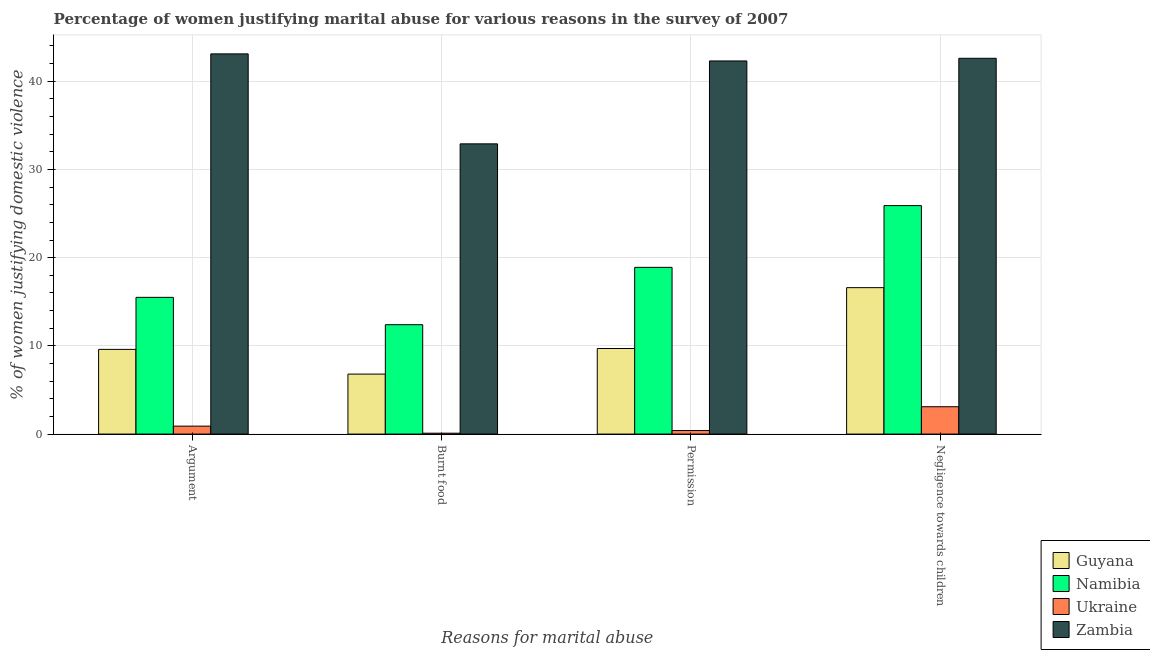How many different coloured bars are there?
Give a very brief answer. 4. What is the label of the 1st group of bars from the left?
Provide a succinct answer. Argument. What is the percentage of women justifying abuse for going without permission in Namibia?
Offer a terse response. 18.9. Across all countries, what is the maximum percentage of women justifying abuse for burning food?
Give a very brief answer. 32.9. In which country was the percentage of women justifying abuse in the case of an argument maximum?
Make the answer very short. Zambia. In which country was the percentage of women justifying abuse in the case of an argument minimum?
Keep it short and to the point. Ukraine. What is the total percentage of women justifying abuse for burning food in the graph?
Your answer should be compact. 52.2. What is the difference between the percentage of women justifying abuse for going without permission in Namibia and that in Zambia?
Give a very brief answer. -23.4. What is the difference between the percentage of women justifying abuse for showing negligence towards children in Guyana and the percentage of women justifying abuse in the case of an argument in Namibia?
Offer a terse response. 1.1. What is the average percentage of women justifying abuse in the case of an argument per country?
Provide a succinct answer. 17.27. What is the ratio of the percentage of women justifying abuse in the case of an argument in Ukraine to that in Namibia?
Your answer should be very brief. 0.06. What is the difference between the highest and the second highest percentage of women justifying abuse for going without permission?
Provide a short and direct response. 23.4. What is the difference between the highest and the lowest percentage of women justifying abuse for showing negligence towards children?
Give a very brief answer. 39.5. Is it the case that in every country, the sum of the percentage of women justifying abuse for burning food and percentage of women justifying abuse for going without permission is greater than the sum of percentage of women justifying abuse for showing negligence towards children and percentage of women justifying abuse in the case of an argument?
Provide a short and direct response. No. What does the 1st bar from the left in Argument represents?
Provide a short and direct response. Guyana. What does the 1st bar from the right in Negligence towards children represents?
Ensure brevity in your answer.  Zambia. How many bars are there?
Your response must be concise. 16. What is the difference between two consecutive major ticks on the Y-axis?
Your response must be concise. 10. Does the graph contain any zero values?
Give a very brief answer. No. Where does the legend appear in the graph?
Ensure brevity in your answer.  Bottom right. How many legend labels are there?
Your response must be concise. 4. What is the title of the graph?
Your response must be concise. Percentage of women justifying marital abuse for various reasons in the survey of 2007. Does "Guyana" appear as one of the legend labels in the graph?
Your response must be concise. Yes. What is the label or title of the X-axis?
Your answer should be compact. Reasons for marital abuse. What is the label or title of the Y-axis?
Provide a succinct answer. % of women justifying domestic violence. What is the % of women justifying domestic violence in Ukraine in Argument?
Your answer should be very brief. 0.9. What is the % of women justifying domestic violence in Zambia in Argument?
Your answer should be very brief. 43.1. What is the % of women justifying domestic violence of Zambia in Burnt food?
Offer a very short reply. 32.9. What is the % of women justifying domestic violence of Zambia in Permission?
Offer a very short reply. 42.3. What is the % of women justifying domestic violence of Namibia in Negligence towards children?
Make the answer very short. 25.9. What is the % of women justifying domestic violence in Ukraine in Negligence towards children?
Keep it short and to the point. 3.1. What is the % of women justifying domestic violence in Zambia in Negligence towards children?
Provide a short and direct response. 42.6. Across all Reasons for marital abuse, what is the maximum % of women justifying domestic violence of Guyana?
Your answer should be very brief. 16.6. Across all Reasons for marital abuse, what is the maximum % of women justifying domestic violence of Namibia?
Your response must be concise. 25.9. Across all Reasons for marital abuse, what is the maximum % of women justifying domestic violence in Zambia?
Your response must be concise. 43.1. Across all Reasons for marital abuse, what is the minimum % of women justifying domestic violence in Guyana?
Offer a terse response. 6.8. Across all Reasons for marital abuse, what is the minimum % of women justifying domestic violence in Namibia?
Offer a terse response. 12.4. Across all Reasons for marital abuse, what is the minimum % of women justifying domestic violence in Ukraine?
Make the answer very short. 0.1. Across all Reasons for marital abuse, what is the minimum % of women justifying domestic violence of Zambia?
Offer a very short reply. 32.9. What is the total % of women justifying domestic violence in Guyana in the graph?
Offer a terse response. 42.7. What is the total % of women justifying domestic violence in Namibia in the graph?
Give a very brief answer. 72.7. What is the total % of women justifying domestic violence of Ukraine in the graph?
Ensure brevity in your answer.  4.5. What is the total % of women justifying domestic violence of Zambia in the graph?
Your response must be concise. 160.9. What is the difference between the % of women justifying domestic violence of Guyana in Argument and that in Burnt food?
Your response must be concise. 2.8. What is the difference between the % of women justifying domestic violence in Namibia in Argument and that in Permission?
Make the answer very short. -3.4. What is the difference between the % of women justifying domestic violence of Guyana in Argument and that in Negligence towards children?
Offer a very short reply. -7. What is the difference between the % of women justifying domestic violence of Ukraine in Argument and that in Negligence towards children?
Your answer should be very brief. -2.2. What is the difference between the % of women justifying domestic violence in Zambia in Argument and that in Negligence towards children?
Offer a very short reply. 0.5. What is the difference between the % of women justifying domestic violence of Guyana in Burnt food and that in Permission?
Offer a very short reply. -2.9. What is the difference between the % of women justifying domestic violence in Namibia in Burnt food and that in Permission?
Your answer should be very brief. -6.5. What is the difference between the % of women justifying domestic violence of Ukraine in Burnt food and that in Permission?
Keep it short and to the point. -0.3. What is the difference between the % of women justifying domestic violence of Ukraine in Burnt food and that in Negligence towards children?
Your answer should be compact. -3. What is the difference between the % of women justifying domestic violence in Namibia in Permission and that in Negligence towards children?
Provide a succinct answer. -7. What is the difference between the % of women justifying domestic violence in Guyana in Argument and the % of women justifying domestic violence in Zambia in Burnt food?
Make the answer very short. -23.3. What is the difference between the % of women justifying domestic violence in Namibia in Argument and the % of women justifying domestic violence in Zambia in Burnt food?
Keep it short and to the point. -17.4. What is the difference between the % of women justifying domestic violence of Ukraine in Argument and the % of women justifying domestic violence of Zambia in Burnt food?
Offer a terse response. -32. What is the difference between the % of women justifying domestic violence of Guyana in Argument and the % of women justifying domestic violence of Ukraine in Permission?
Provide a succinct answer. 9.2. What is the difference between the % of women justifying domestic violence in Guyana in Argument and the % of women justifying domestic violence in Zambia in Permission?
Your response must be concise. -32.7. What is the difference between the % of women justifying domestic violence of Namibia in Argument and the % of women justifying domestic violence of Zambia in Permission?
Offer a terse response. -26.8. What is the difference between the % of women justifying domestic violence in Ukraine in Argument and the % of women justifying domestic violence in Zambia in Permission?
Your answer should be very brief. -41.4. What is the difference between the % of women justifying domestic violence of Guyana in Argument and the % of women justifying domestic violence of Namibia in Negligence towards children?
Your response must be concise. -16.3. What is the difference between the % of women justifying domestic violence in Guyana in Argument and the % of women justifying domestic violence in Ukraine in Negligence towards children?
Provide a short and direct response. 6.5. What is the difference between the % of women justifying domestic violence in Guyana in Argument and the % of women justifying domestic violence in Zambia in Negligence towards children?
Your response must be concise. -33. What is the difference between the % of women justifying domestic violence of Namibia in Argument and the % of women justifying domestic violence of Ukraine in Negligence towards children?
Offer a terse response. 12.4. What is the difference between the % of women justifying domestic violence in Namibia in Argument and the % of women justifying domestic violence in Zambia in Negligence towards children?
Your answer should be very brief. -27.1. What is the difference between the % of women justifying domestic violence of Ukraine in Argument and the % of women justifying domestic violence of Zambia in Negligence towards children?
Offer a terse response. -41.7. What is the difference between the % of women justifying domestic violence in Guyana in Burnt food and the % of women justifying domestic violence in Namibia in Permission?
Provide a short and direct response. -12.1. What is the difference between the % of women justifying domestic violence in Guyana in Burnt food and the % of women justifying domestic violence in Ukraine in Permission?
Your answer should be compact. 6.4. What is the difference between the % of women justifying domestic violence in Guyana in Burnt food and the % of women justifying domestic violence in Zambia in Permission?
Keep it short and to the point. -35.5. What is the difference between the % of women justifying domestic violence in Namibia in Burnt food and the % of women justifying domestic violence in Ukraine in Permission?
Provide a short and direct response. 12. What is the difference between the % of women justifying domestic violence in Namibia in Burnt food and the % of women justifying domestic violence in Zambia in Permission?
Offer a very short reply. -29.9. What is the difference between the % of women justifying domestic violence of Ukraine in Burnt food and the % of women justifying domestic violence of Zambia in Permission?
Keep it short and to the point. -42.2. What is the difference between the % of women justifying domestic violence in Guyana in Burnt food and the % of women justifying domestic violence in Namibia in Negligence towards children?
Give a very brief answer. -19.1. What is the difference between the % of women justifying domestic violence in Guyana in Burnt food and the % of women justifying domestic violence in Zambia in Negligence towards children?
Your answer should be compact. -35.8. What is the difference between the % of women justifying domestic violence of Namibia in Burnt food and the % of women justifying domestic violence of Zambia in Negligence towards children?
Your answer should be very brief. -30.2. What is the difference between the % of women justifying domestic violence of Ukraine in Burnt food and the % of women justifying domestic violence of Zambia in Negligence towards children?
Give a very brief answer. -42.5. What is the difference between the % of women justifying domestic violence of Guyana in Permission and the % of women justifying domestic violence of Namibia in Negligence towards children?
Provide a succinct answer. -16.2. What is the difference between the % of women justifying domestic violence in Guyana in Permission and the % of women justifying domestic violence in Ukraine in Negligence towards children?
Your response must be concise. 6.6. What is the difference between the % of women justifying domestic violence in Guyana in Permission and the % of women justifying domestic violence in Zambia in Negligence towards children?
Your response must be concise. -32.9. What is the difference between the % of women justifying domestic violence of Namibia in Permission and the % of women justifying domestic violence of Zambia in Negligence towards children?
Provide a short and direct response. -23.7. What is the difference between the % of women justifying domestic violence in Ukraine in Permission and the % of women justifying domestic violence in Zambia in Negligence towards children?
Offer a very short reply. -42.2. What is the average % of women justifying domestic violence in Guyana per Reasons for marital abuse?
Ensure brevity in your answer.  10.68. What is the average % of women justifying domestic violence of Namibia per Reasons for marital abuse?
Your answer should be very brief. 18.18. What is the average % of women justifying domestic violence of Ukraine per Reasons for marital abuse?
Provide a succinct answer. 1.12. What is the average % of women justifying domestic violence of Zambia per Reasons for marital abuse?
Your response must be concise. 40.23. What is the difference between the % of women justifying domestic violence of Guyana and % of women justifying domestic violence of Ukraine in Argument?
Offer a terse response. 8.7. What is the difference between the % of women justifying domestic violence of Guyana and % of women justifying domestic violence of Zambia in Argument?
Make the answer very short. -33.5. What is the difference between the % of women justifying domestic violence of Namibia and % of women justifying domestic violence of Ukraine in Argument?
Keep it short and to the point. 14.6. What is the difference between the % of women justifying domestic violence of Namibia and % of women justifying domestic violence of Zambia in Argument?
Your response must be concise. -27.6. What is the difference between the % of women justifying domestic violence of Ukraine and % of women justifying domestic violence of Zambia in Argument?
Make the answer very short. -42.2. What is the difference between the % of women justifying domestic violence of Guyana and % of women justifying domestic violence of Ukraine in Burnt food?
Offer a terse response. 6.7. What is the difference between the % of women justifying domestic violence of Guyana and % of women justifying domestic violence of Zambia in Burnt food?
Ensure brevity in your answer.  -26.1. What is the difference between the % of women justifying domestic violence of Namibia and % of women justifying domestic violence of Ukraine in Burnt food?
Keep it short and to the point. 12.3. What is the difference between the % of women justifying domestic violence of Namibia and % of women justifying domestic violence of Zambia in Burnt food?
Keep it short and to the point. -20.5. What is the difference between the % of women justifying domestic violence in Ukraine and % of women justifying domestic violence in Zambia in Burnt food?
Your answer should be compact. -32.8. What is the difference between the % of women justifying domestic violence of Guyana and % of women justifying domestic violence of Namibia in Permission?
Offer a terse response. -9.2. What is the difference between the % of women justifying domestic violence in Guyana and % of women justifying domestic violence in Ukraine in Permission?
Provide a short and direct response. 9.3. What is the difference between the % of women justifying domestic violence in Guyana and % of women justifying domestic violence in Zambia in Permission?
Provide a short and direct response. -32.6. What is the difference between the % of women justifying domestic violence in Namibia and % of women justifying domestic violence in Zambia in Permission?
Ensure brevity in your answer.  -23.4. What is the difference between the % of women justifying domestic violence of Ukraine and % of women justifying domestic violence of Zambia in Permission?
Provide a succinct answer. -41.9. What is the difference between the % of women justifying domestic violence of Namibia and % of women justifying domestic violence of Ukraine in Negligence towards children?
Your answer should be very brief. 22.8. What is the difference between the % of women justifying domestic violence in Namibia and % of women justifying domestic violence in Zambia in Negligence towards children?
Keep it short and to the point. -16.7. What is the difference between the % of women justifying domestic violence in Ukraine and % of women justifying domestic violence in Zambia in Negligence towards children?
Your answer should be compact. -39.5. What is the ratio of the % of women justifying domestic violence of Guyana in Argument to that in Burnt food?
Your answer should be compact. 1.41. What is the ratio of the % of women justifying domestic violence in Namibia in Argument to that in Burnt food?
Give a very brief answer. 1.25. What is the ratio of the % of women justifying domestic violence in Ukraine in Argument to that in Burnt food?
Provide a short and direct response. 9. What is the ratio of the % of women justifying domestic violence in Zambia in Argument to that in Burnt food?
Give a very brief answer. 1.31. What is the ratio of the % of women justifying domestic violence in Guyana in Argument to that in Permission?
Your answer should be very brief. 0.99. What is the ratio of the % of women justifying domestic violence of Namibia in Argument to that in Permission?
Provide a short and direct response. 0.82. What is the ratio of the % of women justifying domestic violence in Ukraine in Argument to that in Permission?
Your answer should be compact. 2.25. What is the ratio of the % of women justifying domestic violence of Zambia in Argument to that in Permission?
Provide a short and direct response. 1.02. What is the ratio of the % of women justifying domestic violence of Guyana in Argument to that in Negligence towards children?
Your answer should be compact. 0.58. What is the ratio of the % of women justifying domestic violence of Namibia in Argument to that in Negligence towards children?
Give a very brief answer. 0.6. What is the ratio of the % of women justifying domestic violence of Ukraine in Argument to that in Negligence towards children?
Provide a short and direct response. 0.29. What is the ratio of the % of women justifying domestic violence of Zambia in Argument to that in Negligence towards children?
Make the answer very short. 1.01. What is the ratio of the % of women justifying domestic violence in Guyana in Burnt food to that in Permission?
Your response must be concise. 0.7. What is the ratio of the % of women justifying domestic violence in Namibia in Burnt food to that in Permission?
Provide a short and direct response. 0.66. What is the ratio of the % of women justifying domestic violence of Ukraine in Burnt food to that in Permission?
Provide a succinct answer. 0.25. What is the ratio of the % of women justifying domestic violence in Zambia in Burnt food to that in Permission?
Your answer should be compact. 0.78. What is the ratio of the % of women justifying domestic violence of Guyana in Burnt food to that in Negligence towards children?
Your answer should be very brief. 0.41. What is the ratio of the % of women justifying domestic violence in Namibia in Burnt food to that in Negligence towards children?
Provide a short and direct response. 0.48. What is the ratio of the % of women justifying domestic violence in Ukraine in Burnt food to that in Negligence towards children?
Ensure brevity in your answer.  0.03. What is the ratio of the % of women justifying domestic violence in Zambia in Burnt food to that in Negligence towards children?
Your answer should be compact. 0.77. What is the ratio of the % of women justifying domestic violence in Guyana in Permission to that in Negligence towards children?
Offer a terse response. 0.58. What is the ratio of the % of women justifying domestic violence in Namibia in Permission to that in Negligence towards children?
Offer a terse response. 0.73. What is the ratio of the % of women justifying domestic violence of Ukraine in Permission to that in Negligence towards children?
Provide a succinct answer. 0.13. What is the ratio of the % of women justifying domestic violence in Zambia in Permission to that in Negligence towards children?
Your answer should be compact. 0.99. What is the difference between the highest and the second highest % of women justifying domestic violence of Guyana?
Offer a terse response. 6.9. What is the difference between the highest and the lowest % of women justifying domestic violence of Guyana?
Your answer should be compact. 9.8. What is the difference between the highest and the lowest % of women justifying domestic violence in Zambia?
Give a very brief answer. 10.2. 